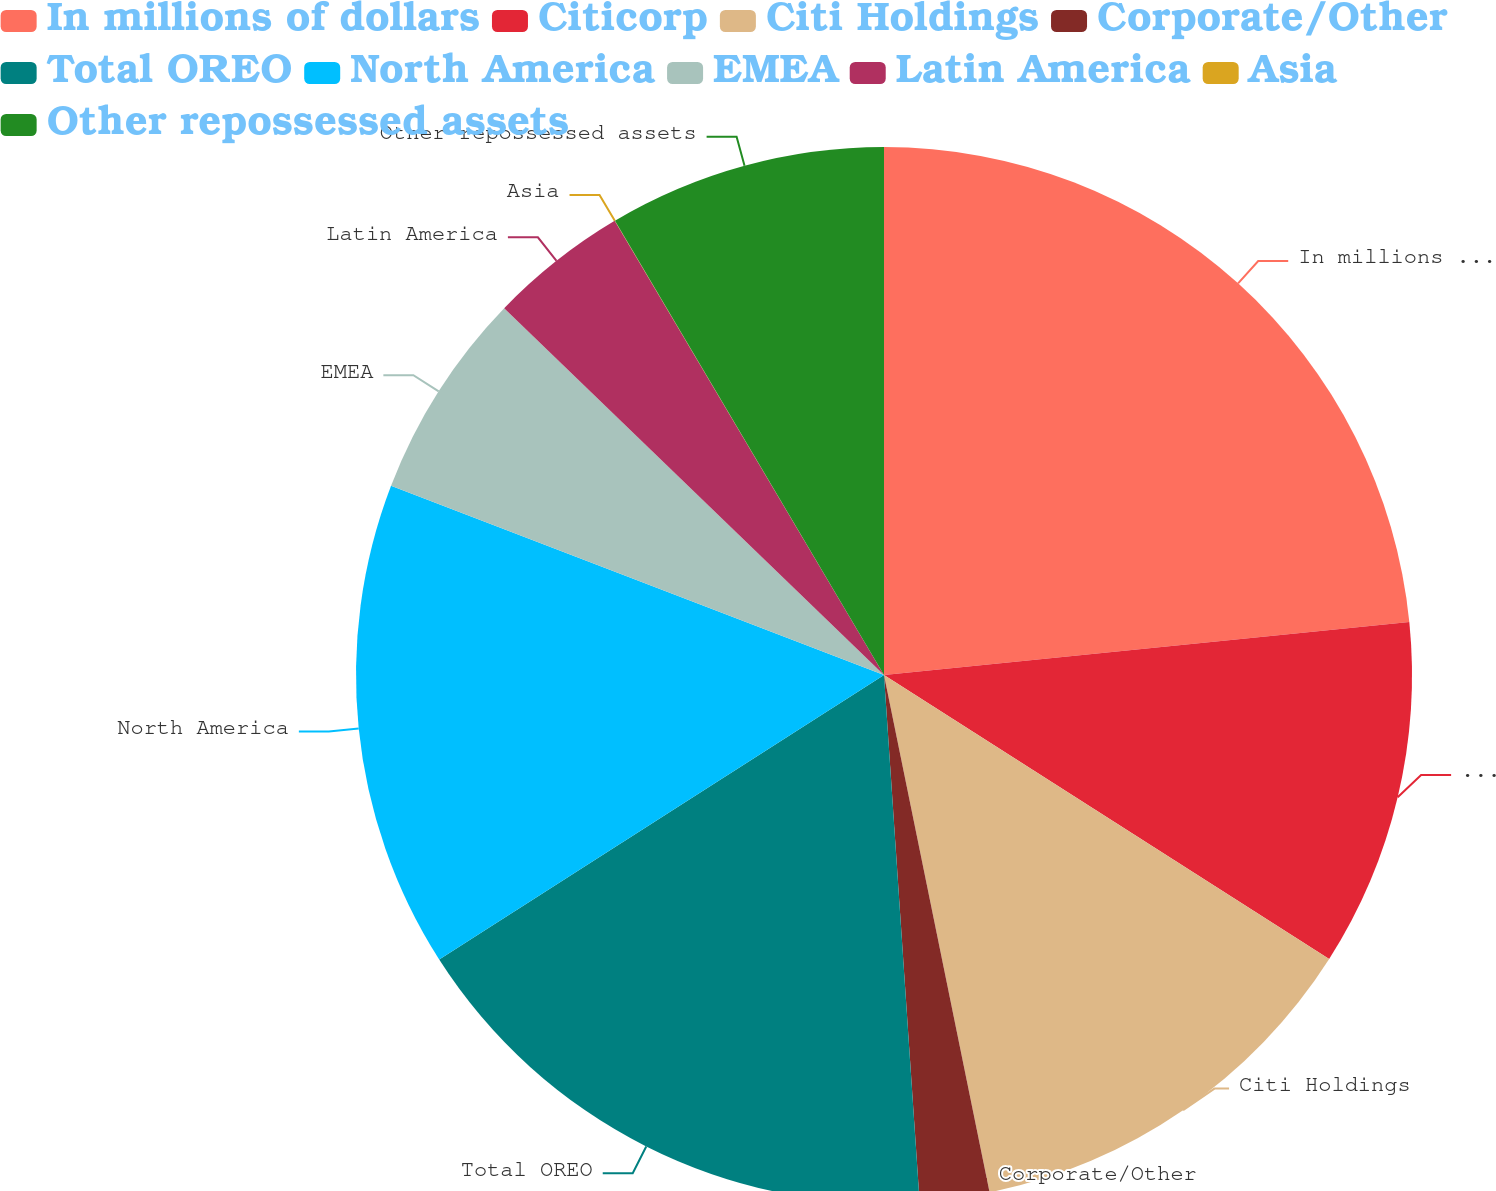Convert chart. <chart><loc_0><loc_0><loc_500><loc_500><pie_chart><fcel>In millions of dollars<fcel>Citicorp<fcel>Citi Holdings<fcel>Corporate/Other<fcel>Total OREO<fcel>North America<fcel>EMEA<fcel>Latin America<fcel>Asia<fcel>Other repossessed assets<nl><fcel>23.4%<fcel>10.64%<fcel>12.76%<fcel>2.13%<fcel>17.02%<fcel>14.89%<fcel>6.39%<fcel>4.26%<fcel>0.01%<fcel>8.51%<nl></chart> 